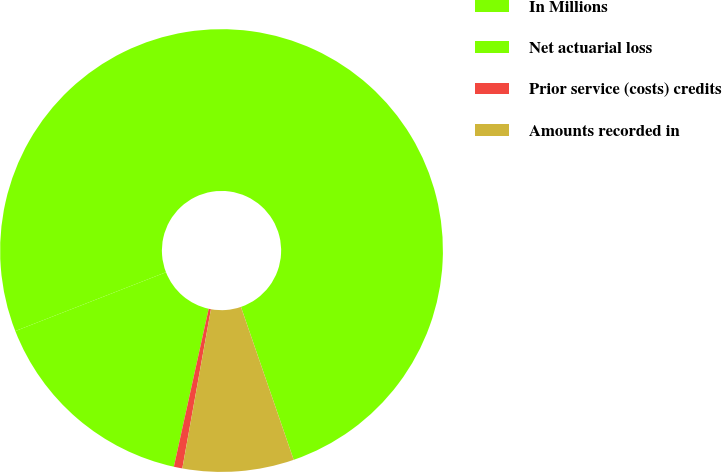Convert chart to OTSL. <chart><loc_0><loc_0><loc_500><loc_500><pie_chart><fcel>In Millions<fcel>Net actuarial loss<fcel>Prior service (costs) credits<fcel>Amounts recorded in<nl><fcel>75.63%<fcel>15.62%<fcel>0.62%<fcel>8.12%<nl></chart> 